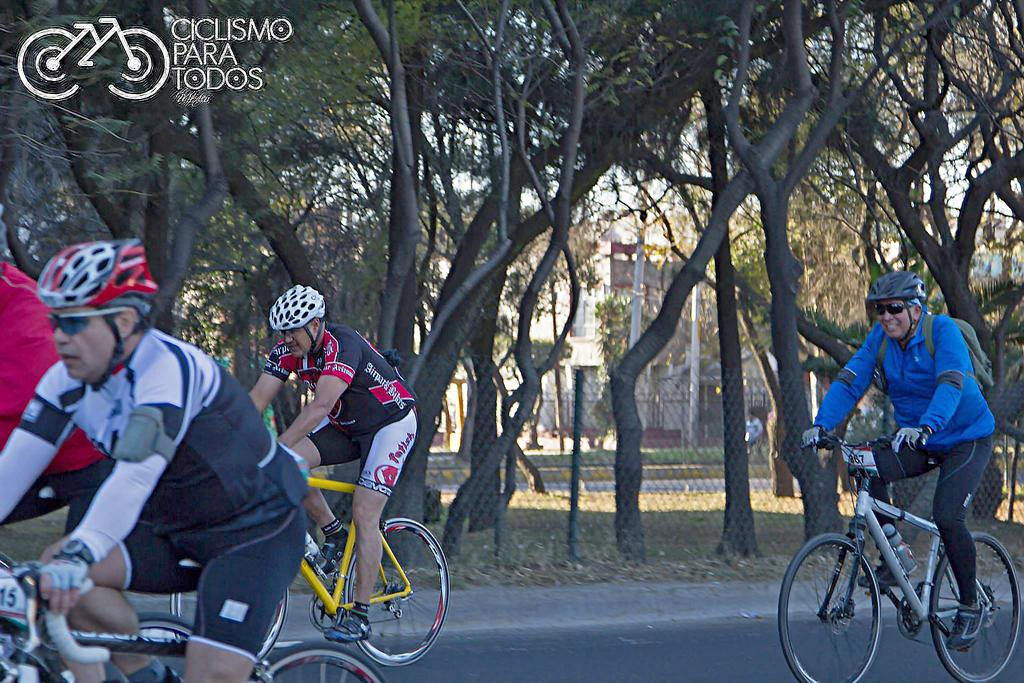What are the persons in the image doing? The persons in the image are riding bicycles on the road. What type of barrier can be seen in the image? There are fences visible in the image. What type of vegetation is present in the image? Trees are present in the image. What type of structures can be seen in the image? There are buildings in the image. What type of vertical structures are visible in the image? Poles are visible in the image. What part of the natural environment is visible in the image? The sky is visible in the image. Can you tell me how many goldfish are swimming in the river in the image? There is no river or goldfish present in the image. What is the fifth element in the image? The provided facts do not mention a fifth element in the image. 